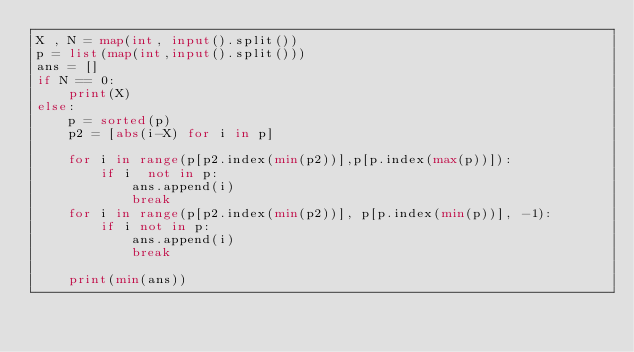<code> <loc_0><loc_0><loc_500><loc_500><_Python_>X , N = map(int, input().split())
p = list(map(int,input().split()))
ans = []
if N == 0:
    print(X)
else:
    p = sorted(p)
    p2 = [abs(i-X) for i in p]

    for i in range(p[p2.index(min(p2))],p[p.index(max(p))]):
        if i  not in p:
            ans.append(i)
            break
    for i in range(p[p2.index(min(p2))], p[p.index(min(p))], -1):
        if i not in p:
            ans.append(i)
            break
 
    print(min(ans))

</code> 